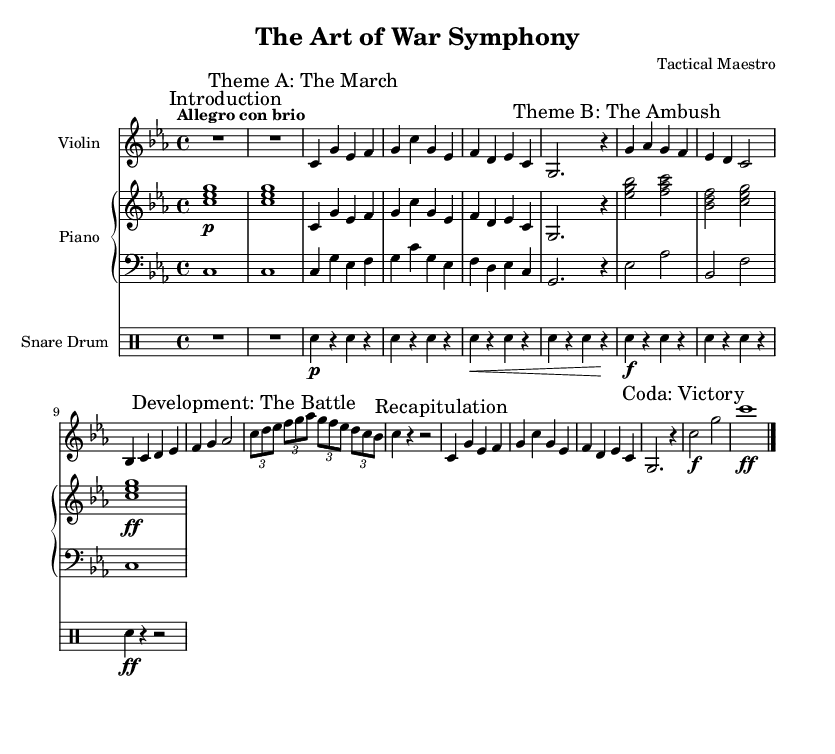What is the key signature of this music? The key signature is C minor, which includes three flats: B flat, E flat, and A flat. This is indicated at the beginning of the score.
Answer: C minor What is the time signature of the piece? The time signature is 4/4, meaning there are four beats per measure and a quarter note receives one beat. This can be identified in the early part of the score.
Answer: 4/4 What is the tempo marking of the symphony? The tempo marking is "Allegro con brio," suggesting a fast and lively pace, which is written at the beginning of the score.
Answer: Allegro con brio Which instrument plays the main theme? The violin primarily plays the main theme throughout the piece, as indicated by the instrument labeled at the start of the staff.
Answer: Violin How many sections are there in the symphony? The score consists of five distinct sections: Introduction, Theme A, Theme B, Development, and Recapitulation followed by a Coda. This is indicated by the marks in the score.
Answer: Five What is the dynamic marking at the end of the piece? The dynamic marking at the end of the piece is "ff," indicating a fortissimo or very strong emphasis on the final notes, shown in the last measure.
Answer: ff What is the thematic element represented by "The March"? "The March" represents a structured and orderly section which corresponds to military maneuvers, reflecting a marching rhythm typical in battle. This is indicated in the thematic description in the score.
Answer: Military maneuvers 